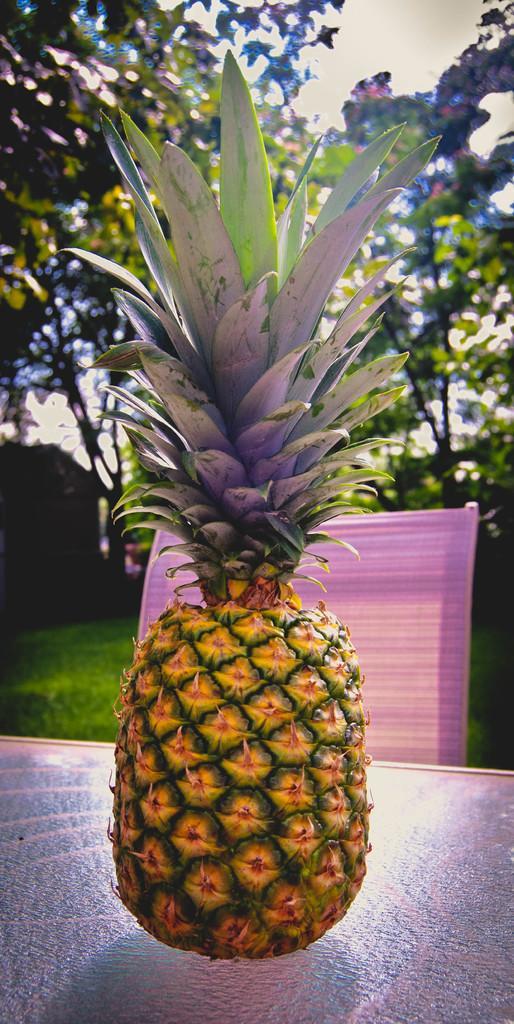Describe this image in one or two sentences. In this image we can see a pineapple fruit on a table and there is a cloth on a chair. In the background we can see trees, grass and sky. 